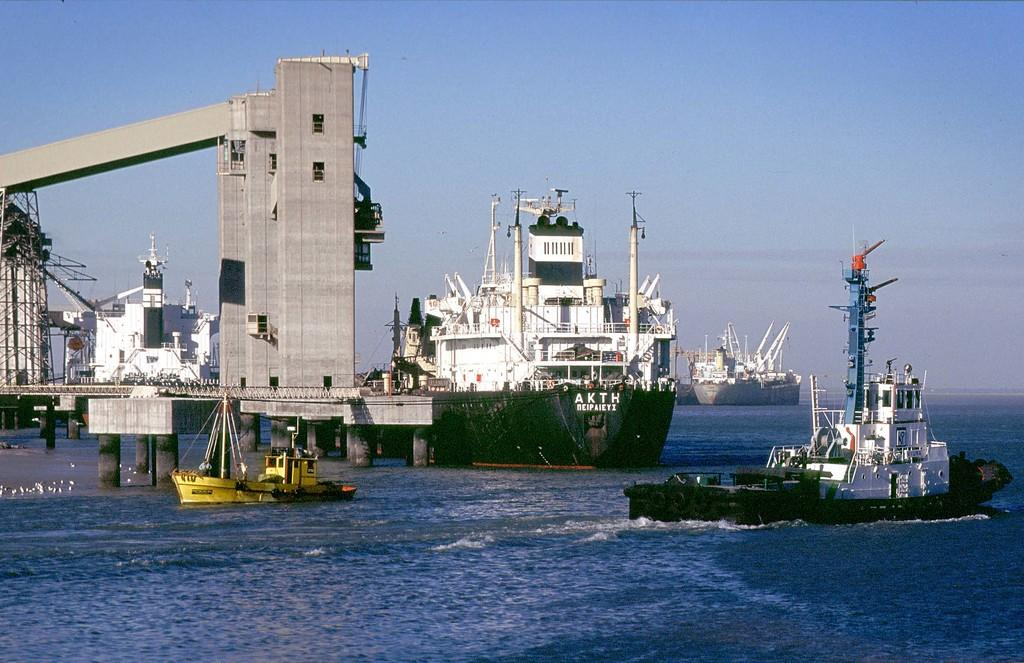<image>
Summarize the visual content of the image. A white and green cargo ship with the text akth on the front of it. 